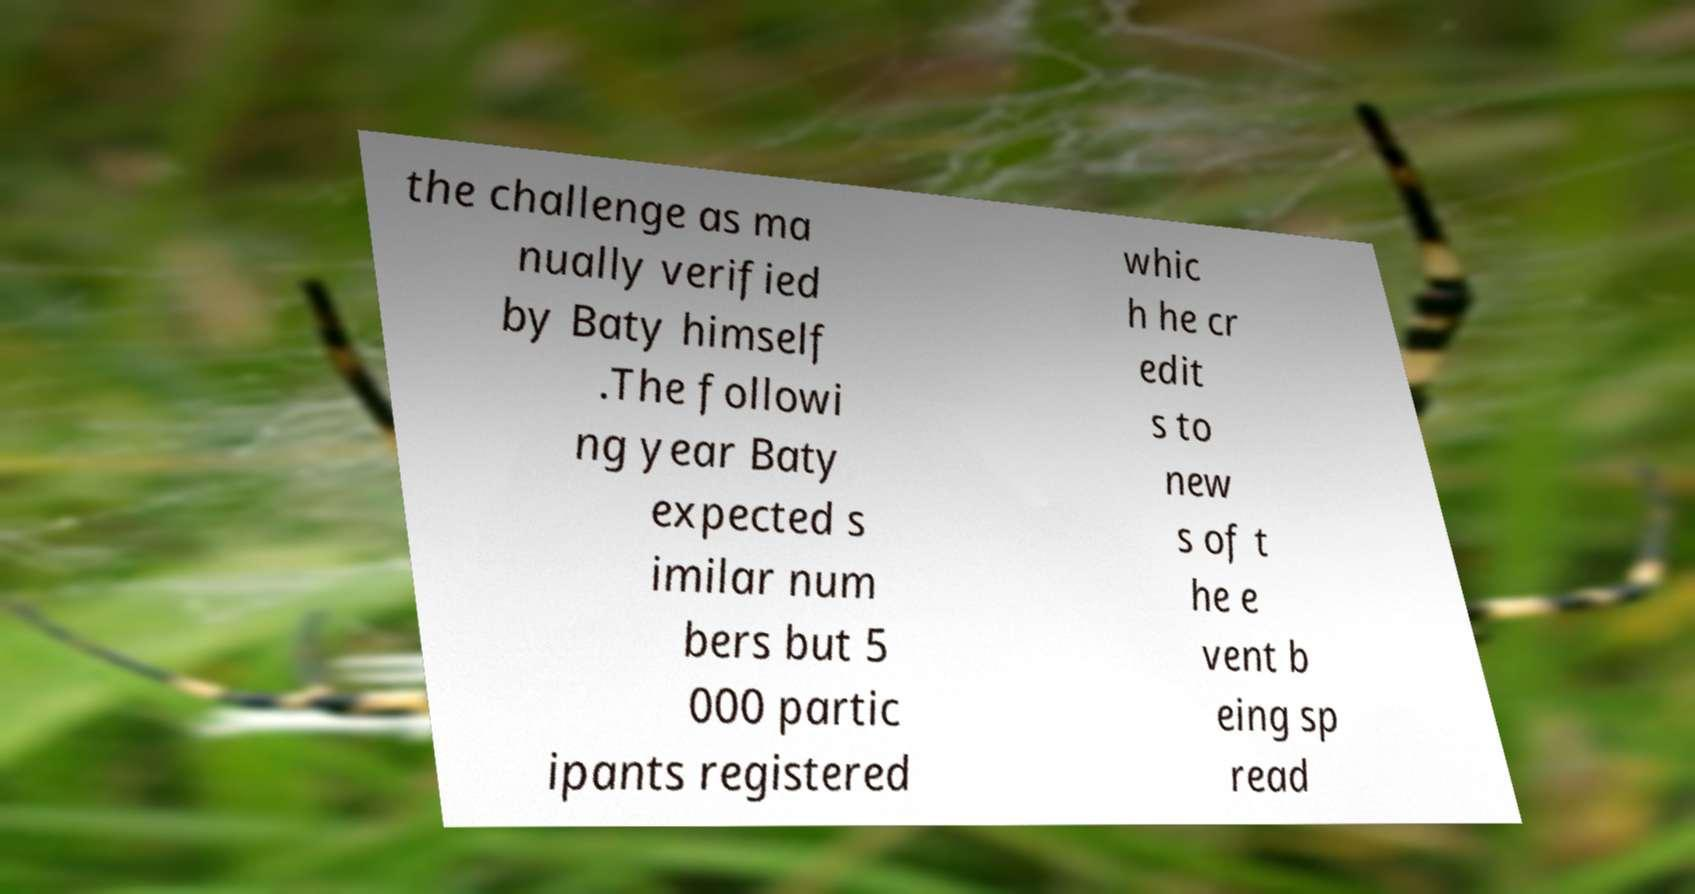Can you read and provide the text displayed in the image?This photo seems to have some interesting text. Can you extract and type it out for me? the challenge as ma nually verified by Baty himself .The followi ng year Baty expected s imilar num bers but 5 000 partic ipants registered whic h he cr edit s to new s of t he e vent b eing sp read 